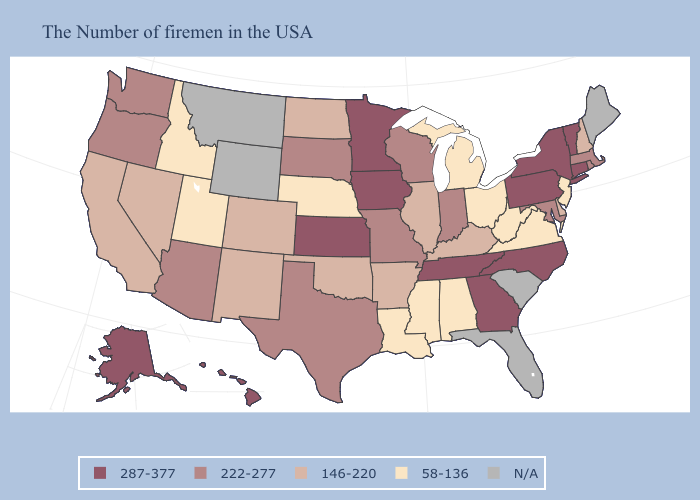Does the map have missing data?
Be succinct. Yes. Name the states that have a value in the range 287-377?
Quick response, please. Vermont, Connecticut, New York, Pennsylvania, North Carolina, Georgia, Tennessee, Minnesota, Iowa, Kansas, Alaska, Hawaii. What is the highest value in states that border Texas?
Keep it brief. 146-220. Name the states that have a value in the range 58-136?
Keep it brief. New Jersey, Virginia, West Virginia, Ohio, Michigan, Alabama, Mississippi, Louisiana, Nebraska, Utah, Idaho. Is the legend a continuous bar?
Keep it brief. No. Does the map have missing data?
Short answer required. Yes. How many symbols are there in the legend?
Short answer required. 5. What is the highest value in the MidWest ?
Concise answer only. 287-377. Name the states that have a value in the range 287-377?
Quick response, please. Vermont, Connecticut, New York, Pennsylvania, North Carolina, Georgia, Tennessee, Minnesota, Iowa, Kansas, Alaska, Hawaii. Among the states that border California , which have the highest value?
Give a very brief answer. Arizona, Oregon. Name the states that have a value in the range 146-220?
Give a very brief answer. New Hampshire, Delaware, Kentucky, Illinois, Arkansas, Oklahoma, North Dakota, Colorado, New Mexico, Nevada, California. What is the value of Maine?
Give a very brief answer. N/A. Among the states that border Arkansas , does Oklahoma have the highest value?
Keep it brief. No. What is the lowest value in states that border West Virginia?
Write a very short answer. 58-136. Does Iowa have the highest value in the USA?
Short answer required. Yes. 